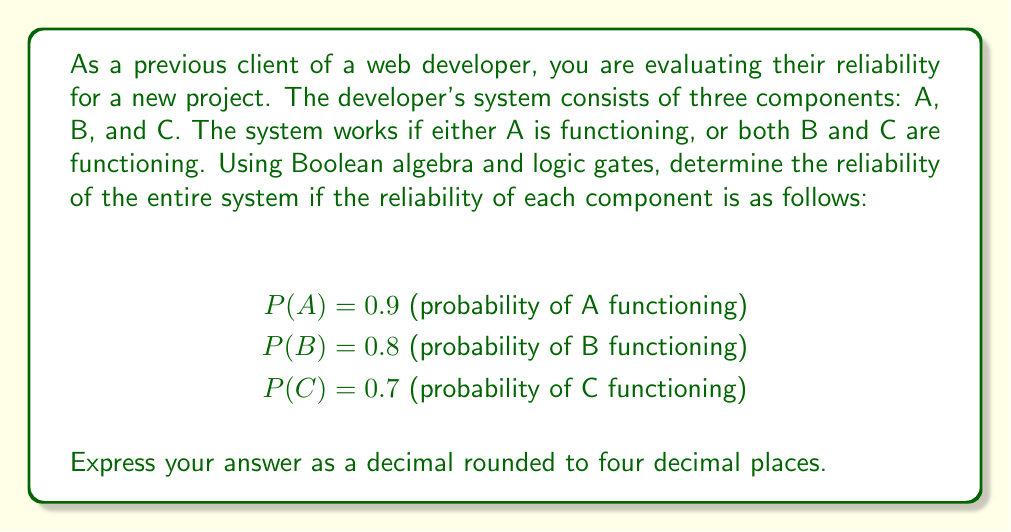Can you solve this math problem? To solve this problem, we'll use Boolean algebra and logic gates to model the system's reliability.

1. First, let's express the system's functionality using Boolean algebra:
   $$ F = A + (B \cdot C) $$
   Where F represents the system functioning, and '+' represents OR, while '·' represents AND.

2. We can represent this using logic gates:
   [asy]
   import geometry;

   pair A = (0,100), B = (0,50), C = (0,0);
   pair AND = (100,25), OR = (200,75);
   
   draw(A--OR);
   draw(B--AND);
   draw(C--AND);
   draw(AND--OR);
   
   label("A", A, W);
   label("B", B, W);
   label("C", C, W);
   label("AND", AND, E);
   label("OR", OR, E);
   label("F", (250,75), E);
   
   dot(A); dot(B); dot(C);
   draw(circle(AND,15));
   draw(circle(OR,15));
   [/asy]

3. To calculate the reliability of the system, we need to find P(F):
   $$ P(F) = P(A + (B \cdot C)) $$

4. Using the addition rule of probability:
   $$ P(F) = P(A) + P(B \cdot C) - P(A \cdot B \cdot C) $$

5. We know P(A) = 0.9. For P(B · C), since B and C are independent:
   $$ P(B \cdot C) = P(B) \cdot P(C) = 0.8 \cdot 0.7 = 0.56 $$

6. For P(A · B · C), since all are independent:
   $$ P(A \cdot B \cdot C) = P(A) \cdot P(B) \cdot P(C) = 0.9 \cdot 0.8 \cdot 0.7 = 0.504 $$

7. Now we can substitute these values into our equation:
   $$ P(F) = 0.9 + 0.56 - 0.504 = 0.956 $$

8. Rounding to four decimal places:
   $$ P(F) \approx 0.9560 $$

Therefore, the reliability of the entire system is approximately 0.9560 or 95.60%.
Answer: 0.9560 